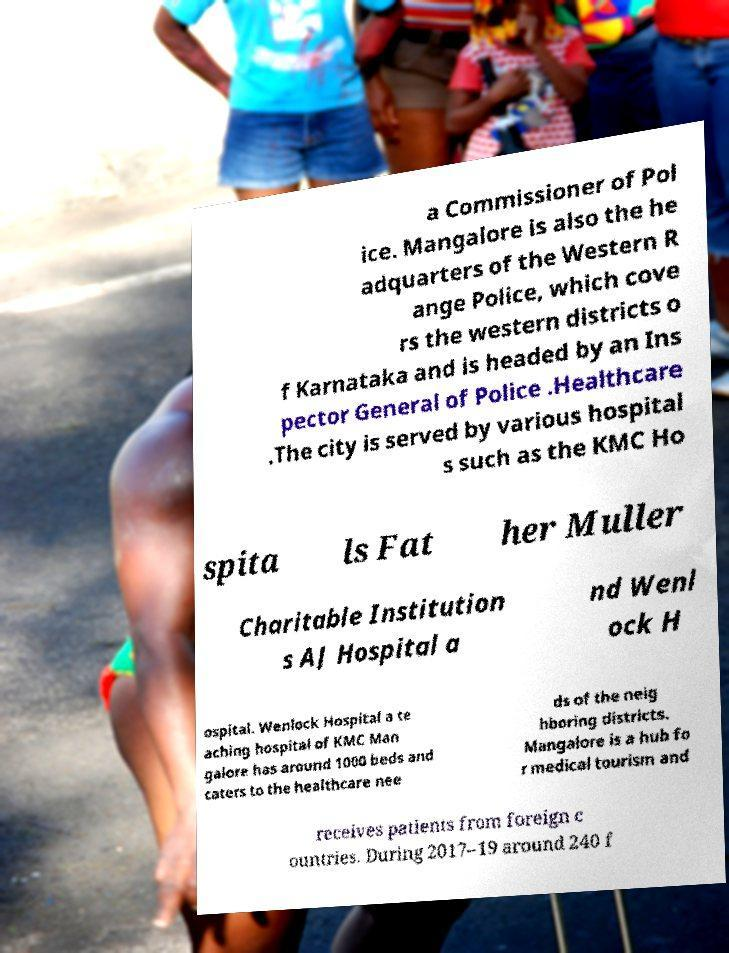For documentation purposes, I need the text within this image transcribed. Could you provide that? a Commissioner of Pol ice. Mangalore is also the he adquarters of the Western R ange Police, which cove rs the western districts o f Karnataka and is headed by an Ins pector General of Police .Healthcare .The city is served by various hospital s such as the KMC Ho spita ls Fat her Muller Charitable Institution s AJ Hospital a nd Wenl ock H ospital. Wenlock Hospital a te aching hospital of KMC Man galore has around 1000 beds and caters to the healthcare nee ds of the neig hboring districts. Mangalore is a hub fo r medical tourism and receives patients from foreign c ountries. During 2017–19 around 240 f 